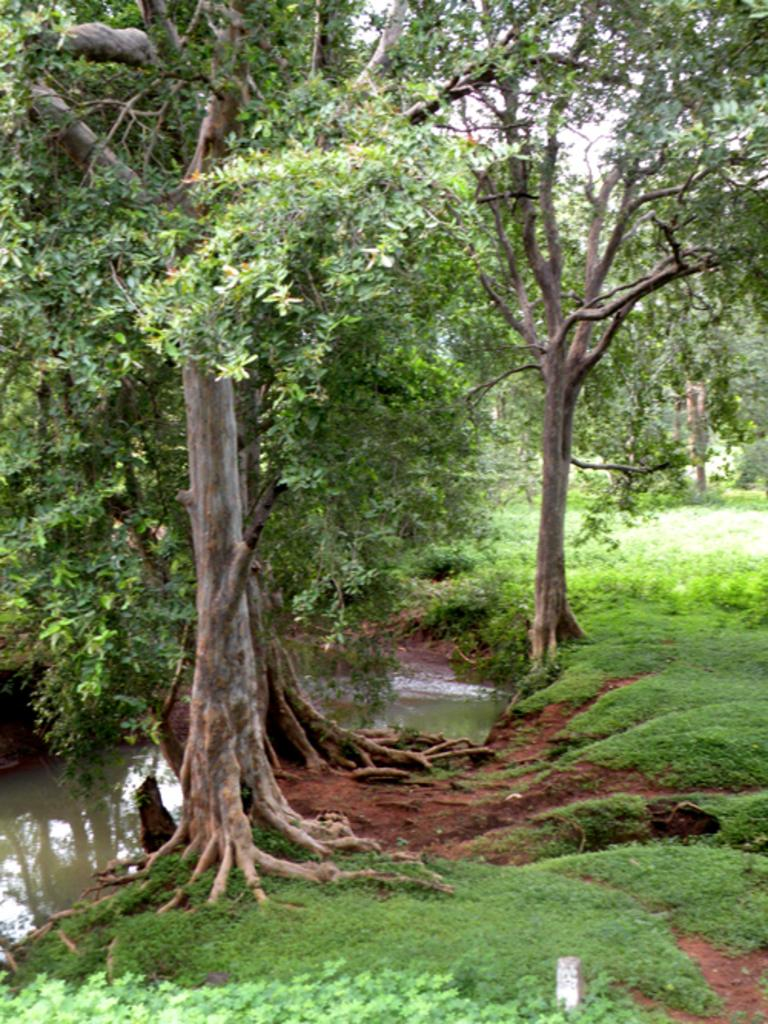What is the primary element visible in the image? There is water in the image. What type of vegetation can be seen in the image? There are trees and grass in the image. What part of the natural environment is visible in the image? The sky is visible in the background of the image. What thoughts are being expressed by the bed in the image? There is no bed present in the image, so it is not possible to determine any thoughts being expressed. 